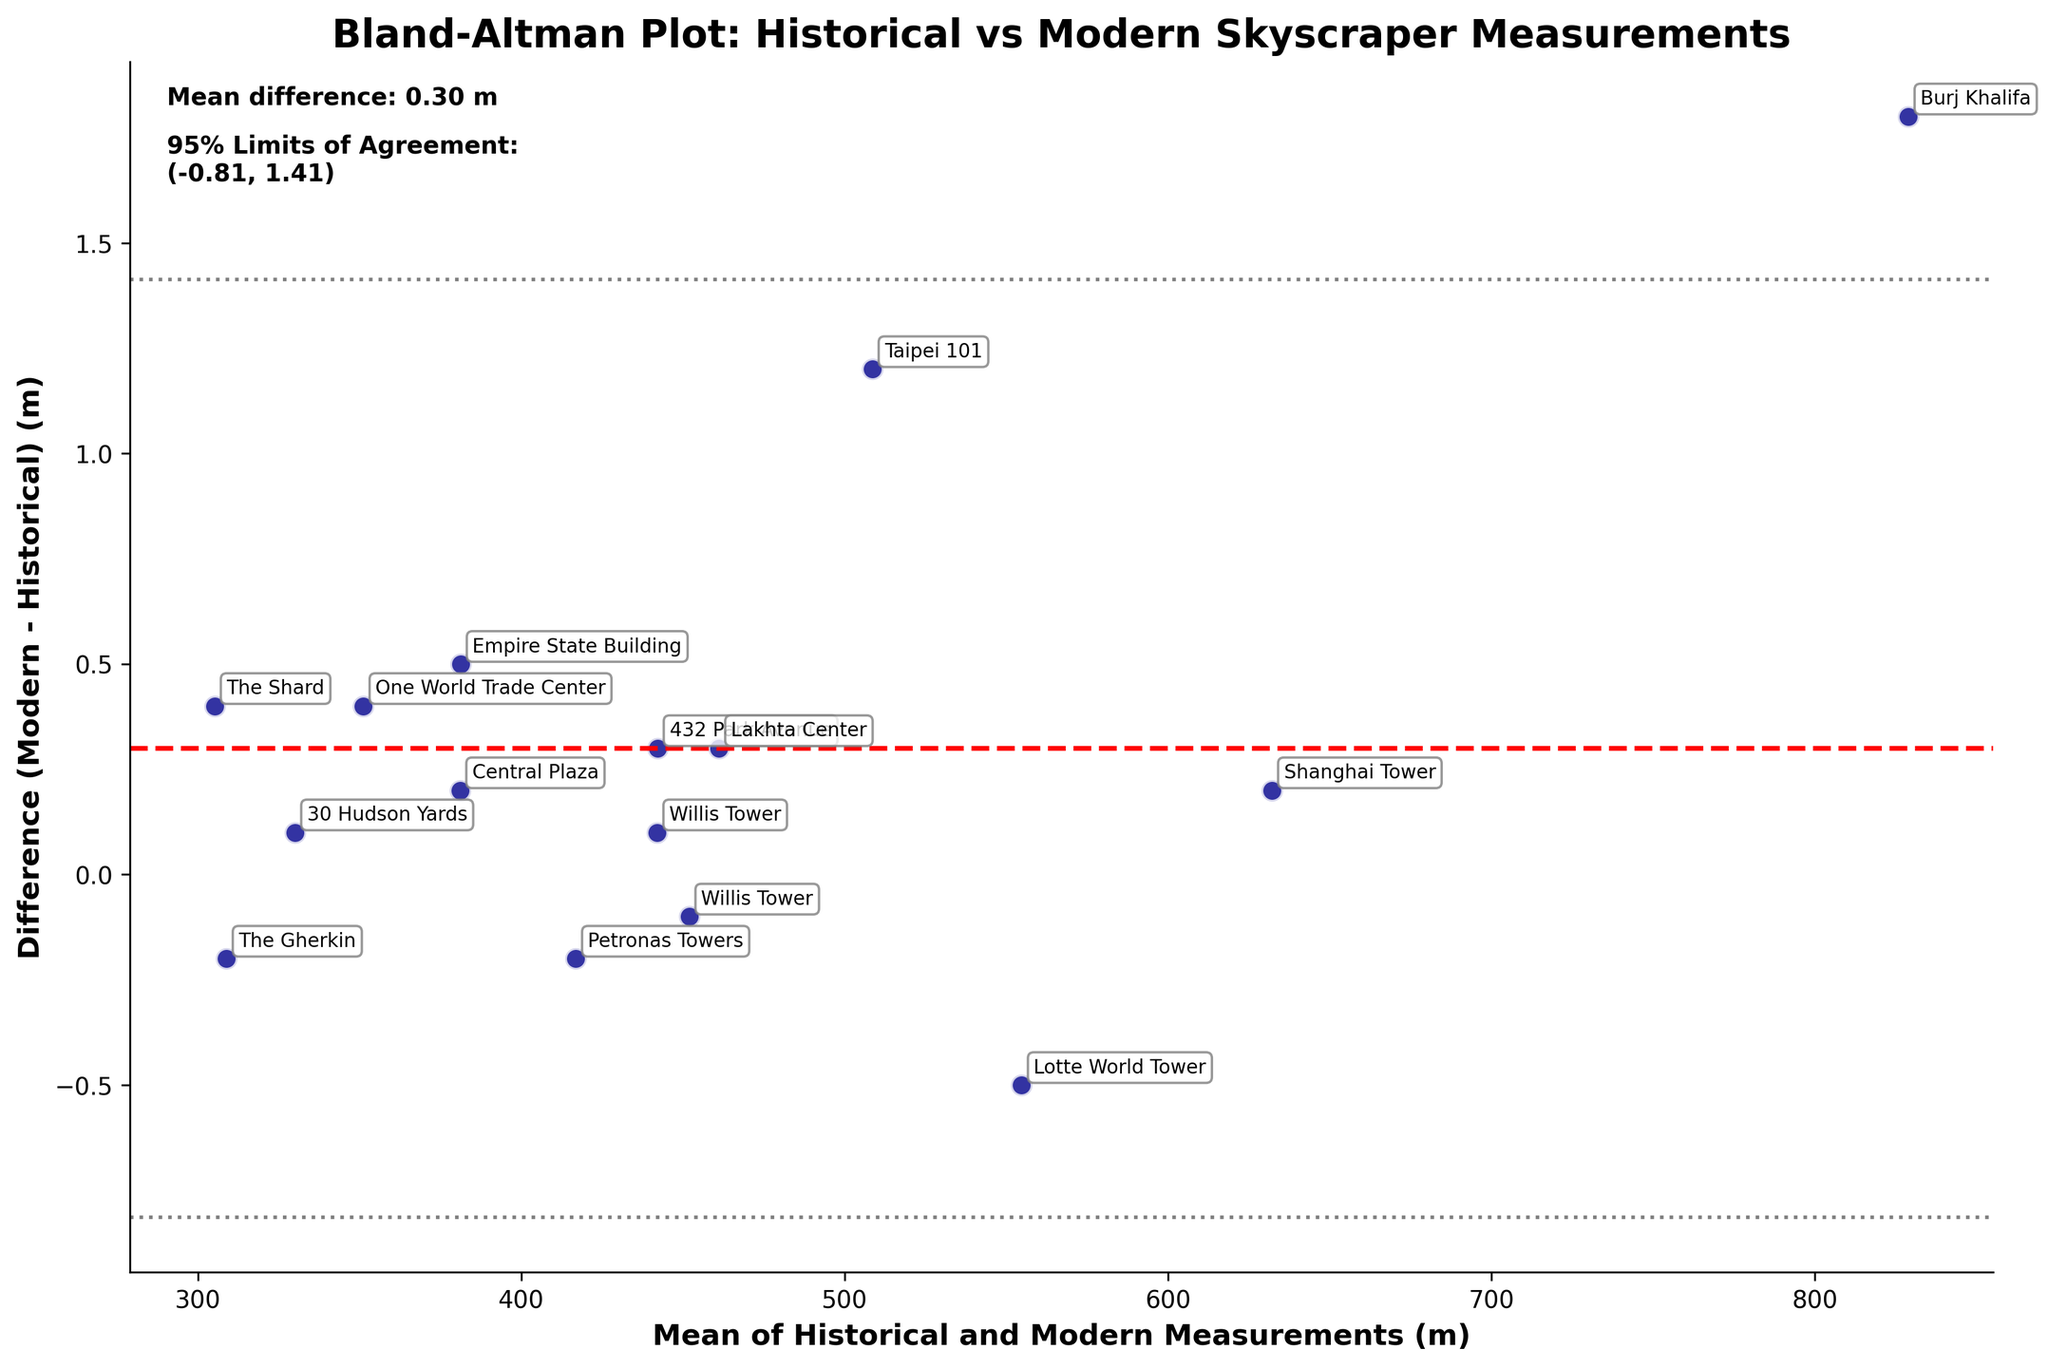What is the mean difference between modern and historical measurements? Look at the value labeled "Mean difference" in the text on the right side of the plot. It shows the average value of the differences between modern and historical measurements.
Answer: 0.71 m What are the 95% limits of agreement for the differences in measurements? The 95% limits of agreement are shown in the text on the right side of the plot. These values are calculated as mean difference ± 1.96 standard deviations of the differences.
Answer: (-0.25, 1.67) m Which building has the largest positive difference between modern and historical measurements? Identify the point on the plot that is the highest above the mean difference line. The corresponding label indicates the building name.
Answer: Burj Khalifa Are there any buildings where the modern measurement is exactly the same as the historical measurement? Look for data points that lie on the horizontal line representing a difference of 0 (no difference). If any exist, note their labels.
Answer: No What is the range of the mean values of historical and modern measurements? The range can be determined by finding the minimum and maximum values on the x-axis, which represents the mean of historical and modern measurements.
Answer: 305.2 to 828.9 m How many buildings have a modern measurement that is higher than the historical measurement? Count the number of data points above the mean difference line on the plot.
Answer: 10 What does the position of most data points relative to the mean difference line indicate about the historical and modern measurements? Most data points are above the mean difference line, indicating that modern measurements are generally higher than historical measurements.
Answer: Modern measurements are generally higher Which buildings have differences that fall outside the 95% limits of agreement? Identify data points that fall above or below the gray dashed lines representing the 95% limits of agreement.
Answer: None What is the building with the smallest difference between modern and historical measurements, and what is that difference? Find the point closest to the mean difference line (0.71 m) and identify its label and the y-value.
Answer: The Gherkin, -0.2 m 